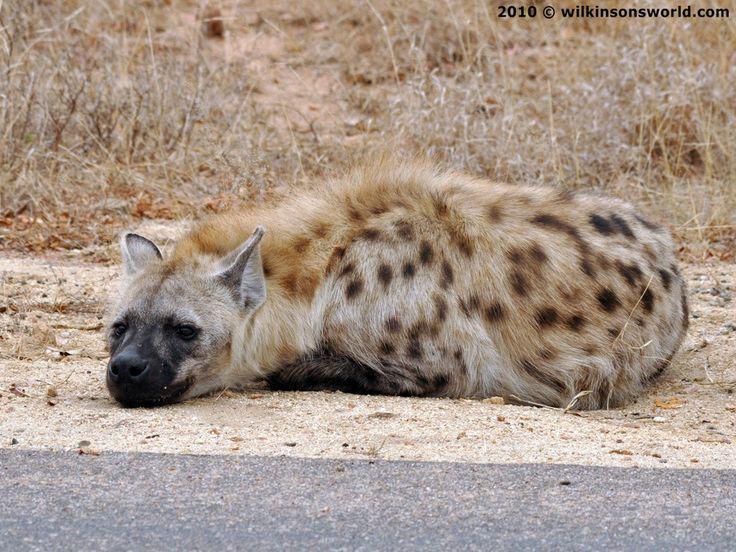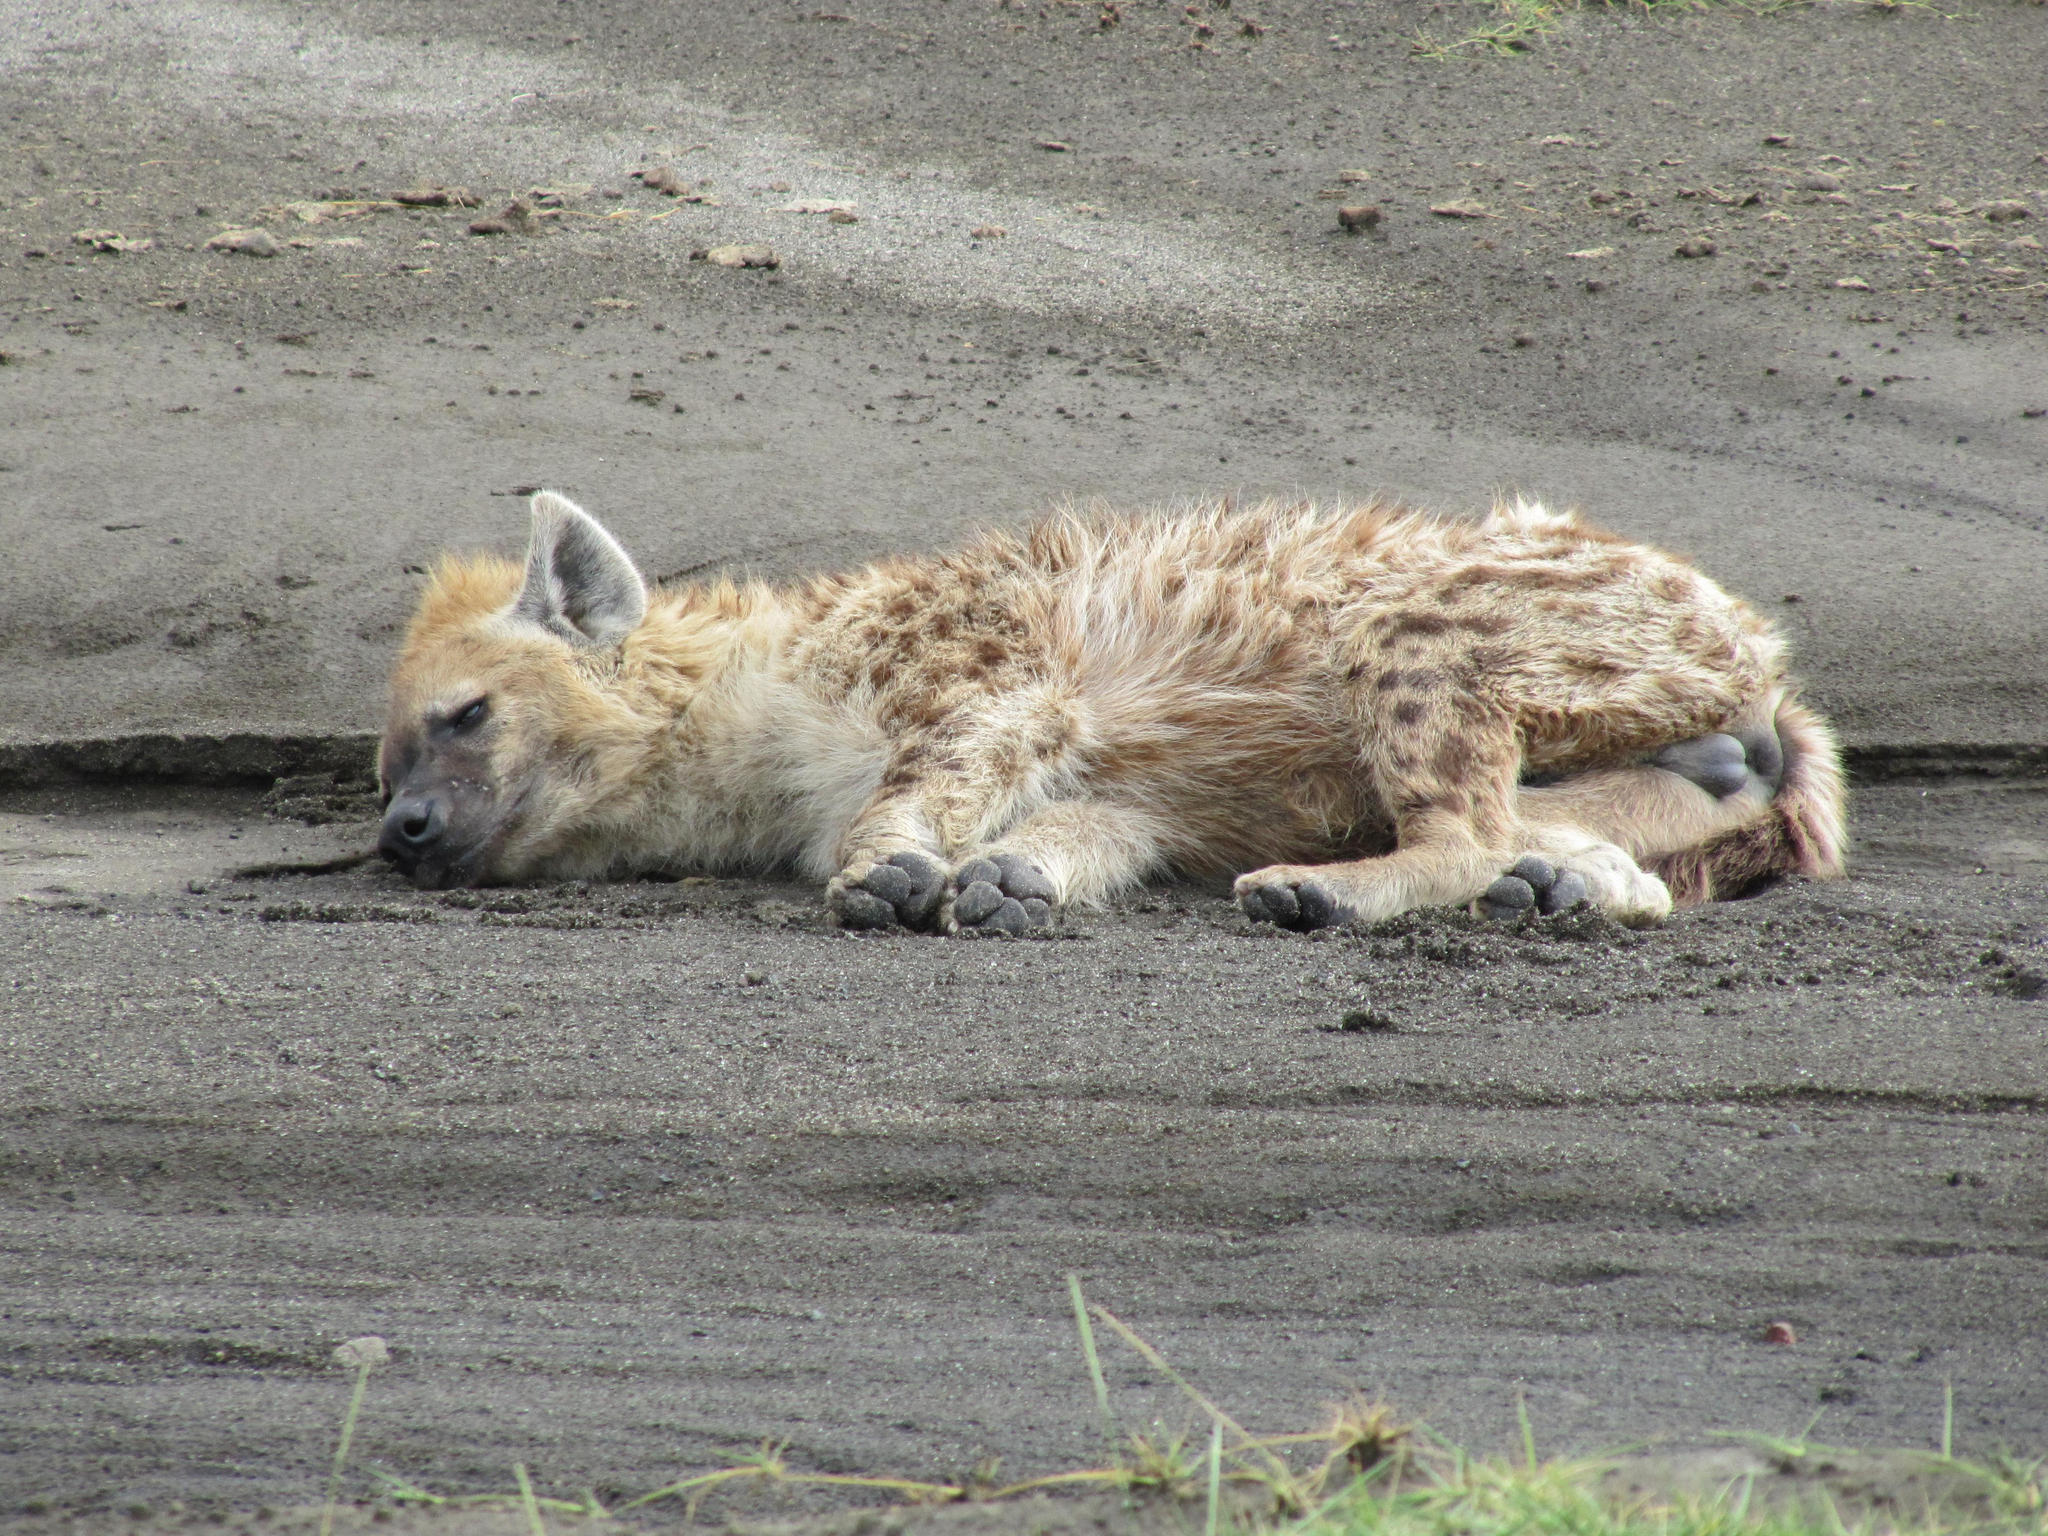The first image is the image on the left, the second image is the image on the right. Assess this claim about the two images: "The animals in both pictures are facing left.". Correct or not? Answer yes or no. Yes. The first image is the image on the left, the second image is the image on the right. Examine the images to the left and right. Is the description "Each image contains exactly one hyena, and each hyena pictured has its head on the left of the image." accurate? Answer yes or no. Yes. 